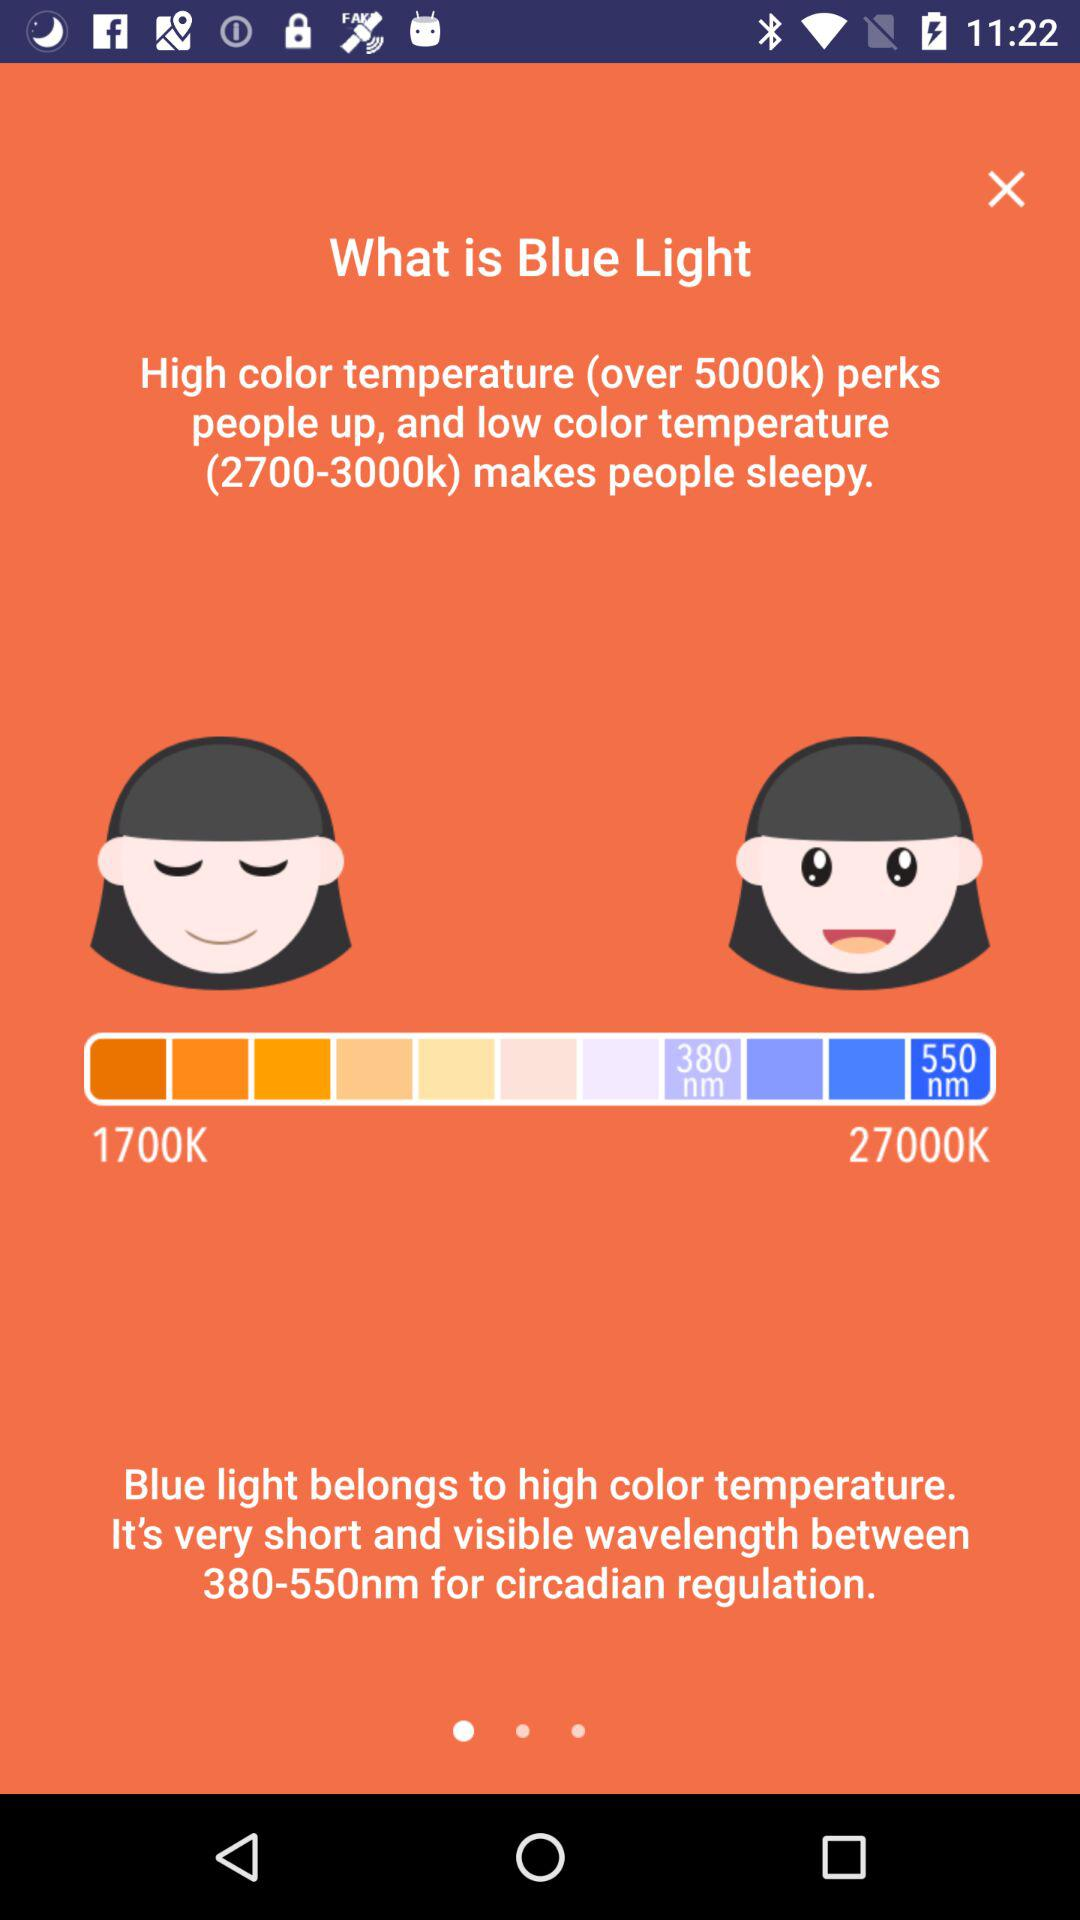What is the lowest color temperature? The lowest color temperature is 1700K. 